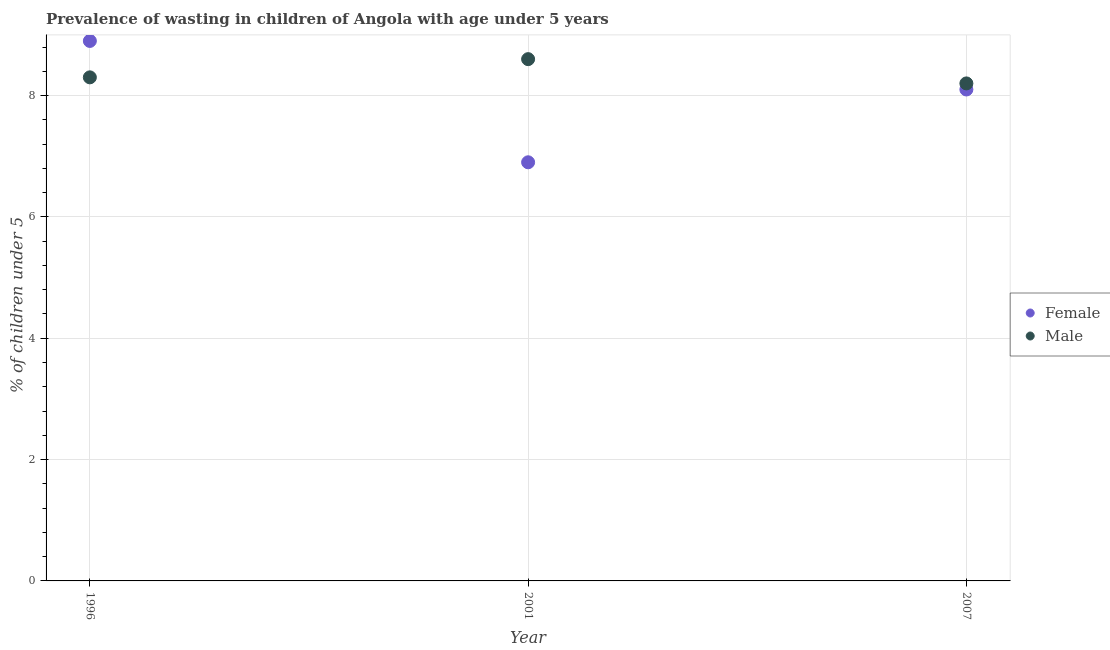How many different coloured dotlines are there?
Your response must be concise. 2. What is the percentage of undernourished female children in 2007?
Provide a succinct answer. 8.1. Across all years, what is the maximum percentage of undernourished male children?
Your answer should be very brief. 8.6. Across all years, what is the minimum percentage of undernourished male children?
Offer a very short reply. 8.2. What is the total percentage of undernourished male children in the graph?
Provide a succinct answer. 25.1. What is the difference between the percentage of undernourished male children in 2001 and that in 2007?
Your response must be concise. 0.4. What is the difference between the percentage of undernourished male children in 2001 and the percentage of undernourished female children in 1996?
Give a very brief answer. -0.3. What is the average percentage of undernourished male children per year?
Your answer should be compact. 8.37. In the year 1996, what is the difference between the percentage of undernourished female children and percentage of undernourished male children?
Ensure brevity in your answer.  0.6. In how many years, is the percentage of undernourished male children greater than 7.2 %?
Your response must be concise. 3. What is the ratio of the percentage of undernourished female children in 1996 to that in 2001?
Offer a terse response. 1.29. Is the difference between the percentage of undernourished female children in 1996 and 2007 greater than the difference between the percentage of undernourished male children in 1996 and 2007?
Your answer should be very brief. Yes. What is the difference between the highest and the second highest percentage of undernourished female children?
Give a very brief answer. 0.8. What is the difference between the highest and the lowest percentage of undernourished female children?
Your answer should be very brief. 2. Is the sum of the percentage of undernourished male children in 1996 and 2007 greater than the maximum percentage of undernourished female children across all years?
Ensure brevity in your answer.  Yes. Does the percentage of undernourished male children monotonically increase over the years?
Ensure brevity in your answer.  No. Is the percentage of undernourished male children strictly greater than the percentage of undernourished female children over the years?
Your response must be concise. No. Is the percentage of undernourished female children strictly less than the percentage of undernourished male children over the years?
Provide a short and direct response. No. What is the difference between two consecutive major ticks on the Y-axis?
Give a very brief answer. 2. Does the graph contain any zero values?
Offer a very short reply. No. Does the graph contain grids?
Your answer should be compact. Yes. Where does the legend appear in the graph?
Your answer should be compact. Center right. How many legend labels are there?
Offer a terse response. 2. How are the legend labels stacked?
Offer a terse response. Vertical. What is the title of the graph?
Provide a short and direct response. Prevalence of wasting in children of Angola with age under 5 years. What is the label or title of the Y-axis?
Make the answer very short.  % of children under 5. What is the  % of children under 5 in Female in 1996?
Give a very brief answer. 8.9. What is the  % of children under 5 of Male in 1996?
Provide a short and direct response. 8.3. What is the  % of children under 5 in Female in 2001?
Offer a terse response. 6.9. What is the  % of children under 5 in Male in 2001?
Offer a very short reply. 8.6. What is the  % of children under 5 in Female in 2007?
Make the answer very short. 8.1. What is the  % of children under 5 in Male in 2007?
Offer a very short reply. 8.2. Across all years, what is the maximum  % of children under 5 of Female?
Give a very brief answer. 8.9. Across all years, what is the maximum  % of children under 5 of Male?
Ensure brevity in your answer.  8.6. Across all years, what is the minimum  % of children under 5 of Female?
Your answer should be compact. 6.9. Across all years, what is the minimum  % of children under 5 of Male?
Keep it short and to the point. 8.2. What is the total  % of children under 5 of Female in the graph?
Your answer should be very brief. 23.9. What is the total  % of children under 5 of Male in the graph?
Give a very brief answer. 25.1. What is the difference between the  % of children under 5 of Female in 1996 and that in 2001?
Ensure brevity in your answer.  2. What is the difference between the  % of children under 5 in Male in 2001 and that in 2007?
Provide a short and direct response. 0.4. What is the difference between the  % of children under 5 in Female in 1996 and the  % of children under 5 in Male in 2001?
Give a very brief answer. 0.3. What is the difference between the  % of children under 5 of Female in 1996 and the  % of children under 5 of Male in 2007?
Make the answer very short. 0.7. What is the average  % of children under 5 of Female per year?
Your answer should be very brief. 7.97. What is the average  % of children under 5 in Male per year?
Ensure brevity in your answer.  8.37. In the year 1996, what is the difference between the  % of children under 5 in Female and  % of children under 5 in Male?
Offer a terse response. 0.6. In the year 2001, what is the difference between the  % of children under 5 of Female and  % of children under 5 of Male?
Your answer should be very brief. -1.7. What is the ratio of the  % of children under 5 of Female in 1996 to that in 2001?
Offer a very short reply. 1.29. What is the ratio of the  % of children under 5 in Male in 1996 to that in 2001?
Ensure brevity in your answer.  0.97. What is the ratio of the  % of children under 5 in Female in 1996 to that in 2007?
Provide a short and direct response. 1.1. What is the ratio of the  % of children under 5 in Male in 1996 to that in 2007?
Make the answer very short. 1.01. What is the ratio of the  % of children under 5 in Female in 2001 to that in 2007?
Your answer should be very brief. 0.85. What is the ratio of the  % of children under 5 in Male in 2001 to that in 2007?
Give a very brief answer. 1.05. What is the difference between the highest and the second highest  % of children under 5 in Male?
Your answer should be compact. 0.3. What is the difference between the highest and the lowest  % of children under 5 in Female?
Your answer should be very brief. 2. What is the difference between the highest and the lowest  % of children under 5 of Male?
Your response must be concise. 0.4. 